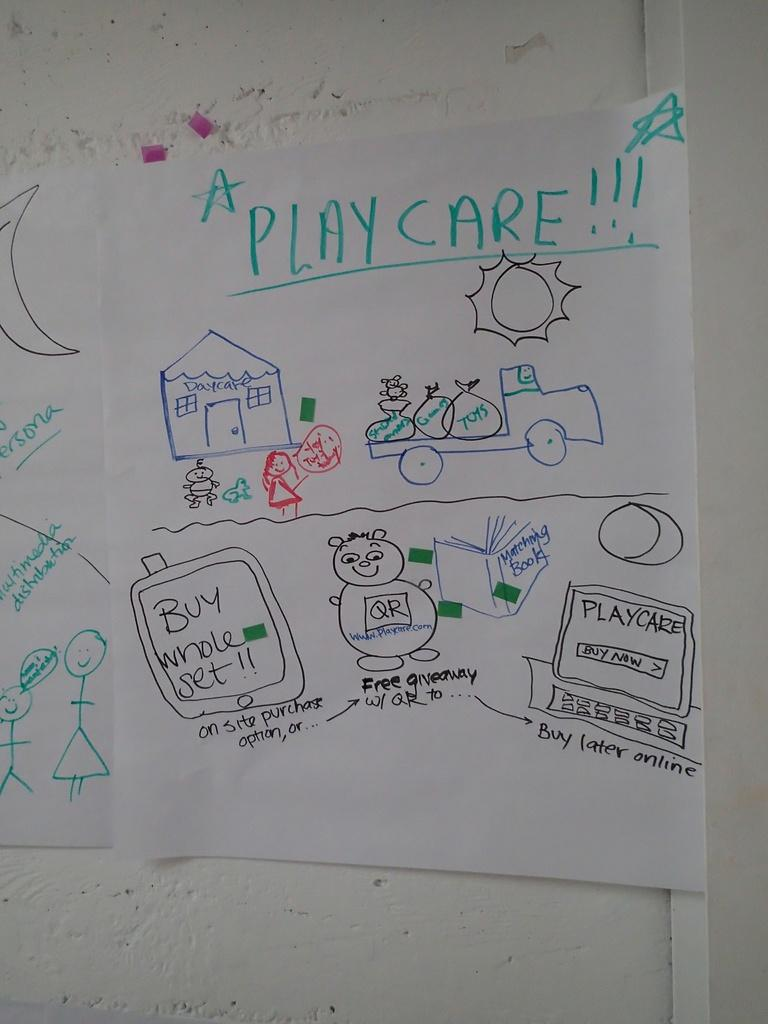<image>
Provide a brief description of the given image. A children's drawing taped on the wall that reads A play care 